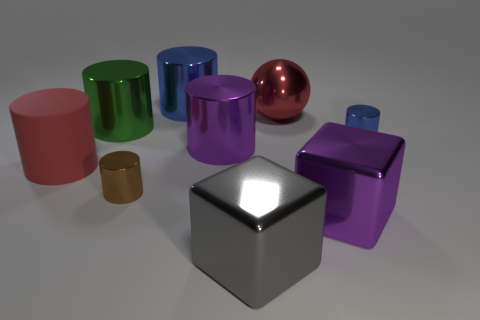Subtract all purple cubes. How many cubes are left? 1 Subtract all large purple cylinders. How many cylinders are left? 5 Subtract all cylinders. How many objects are left? 3 Subtract all gray cylinders. Subtract all cyan cubes. How many cylinders are left? 6 Subtract all blue blocks. How many purple balls are left? 0 Subtract all small brown cylinders. Subtract all green objects. How many objects are left? 7 Add 4 brown metal things. How many brown metal things are left? 5 Add 5 cubes. How many cubes exist? 7 Subtract 0 purple spheres. How many objects are left? 9 Subtract 4 cylinders. How many cylinders are left? 2 